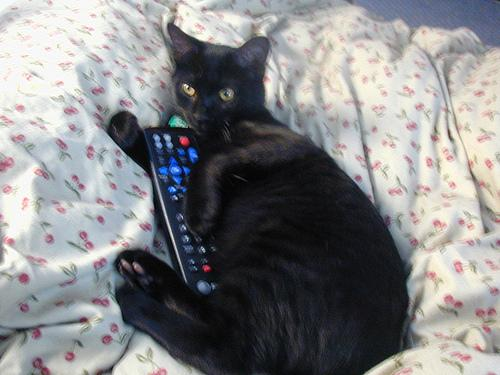What is the cat in control of? Please explain your reasoning. television. The controller has many buttons including numbers for changing channels. 